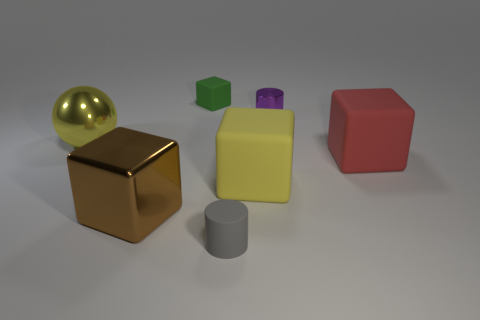Subtract 1 blocks. How many blocks are left? 3 Add 2 big yellow cylinders. How many objects exist? 9 Subtract all cylinders. How many objects are left? 5 Subtract all tiny gray matte cylinders. Subtract all big metal cubes. How many objects are left? 5 Add 1 large red cubes. How many large red cubes are left? 2 Add 6 small blue rubber cylinders. How many small blue rubber cylinders exist? 6 Subtract 1 yellow balls. How many objects are left? 6 